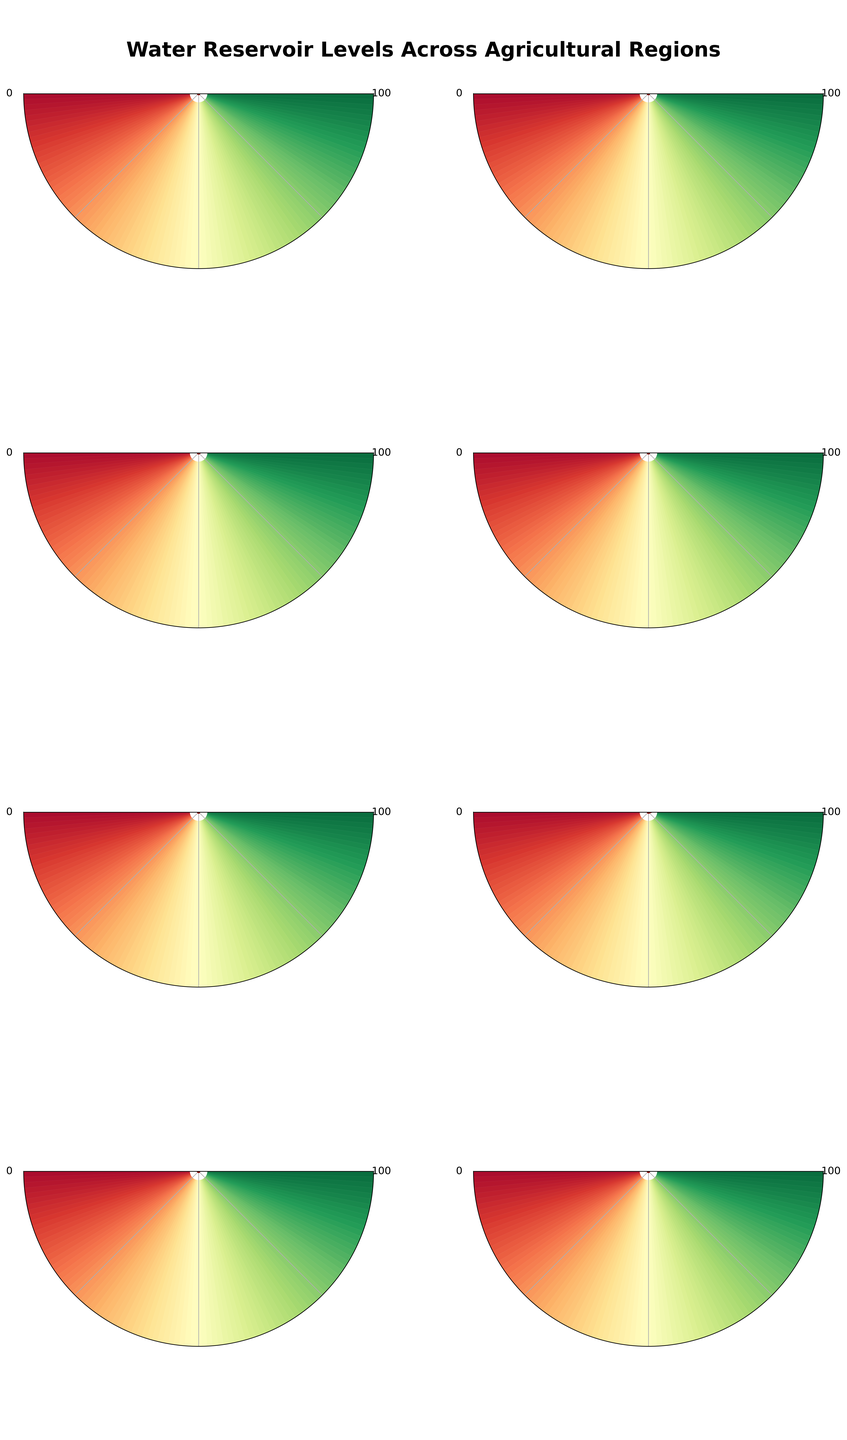What's the water reservoir level in the Central Valley (California)? Based on the gauge for Central Valley (California), the needle points to 35%
Answer: 35% How many regions have water reservoir levels above 50%? The regions with more than 50% water reservoir levels are Midwest Corn Belt, Great Plains, Snake River Plain (Idaho), Mississippi Delta, and Columbia Basin
Answer: 5 Which region has the lowest water reservoir level? By observing the gauges, the Colorado River Basin has the needle pointing to 28%, which is the lowest
Answer: Colorado River Basin Compare the reservoir levels of Texas Panhandle and Columbia Basin. Which one is higher? Texas Panhandle's gauge points to 42%, while Columbia Basin's gauge points to 67%. So, Columbia Basin is higher
Answer: Columbia Basin Which region is at the highest risk of drought based on reservoir level? Colorado River Basin has the lowest reservoir level at 28%, indicating the highest risk of drought
Answer: Colorado River Basin What is the average reservoir level of all regions? Add all the levels and divide by the number of regions: (35 + 42 + 78 + 61 + 53 + 89 + 28 + 67) / 8 = 453 / 8 = 56.625
Answer: 56.625% Rank the regions from highest to lowest reservoir levels. Observing the gauges, the ranking from highest to lowest is Mississippi Delta, Midwest Corn Belt, Columbia Basin, Great Plains, Snake River Plain (Idaho), Texas Panhandle, Central Valley (California), Colorado River Basin
Answer: Mississippi Delta, Midwest Corn Belt, Columbia Basin, Great Plains, Snake River Plain, Texas Panhandle, Central Valley, Colorado River Basin What is the median reservoir level among all the regions? Sort the levels: (28, 35, 42, 53, 61, 67, 78, 89). The median is the average of the 4th and 5th values in the sorted list: (53 + 61) / 2 = 57
Answer: 57% Which region needs immediate attention due to water scarcity? With the reservoir level at 28%, Colorado River Basin clearly needs the most immediate attention
Answer: Colorado River Basin 